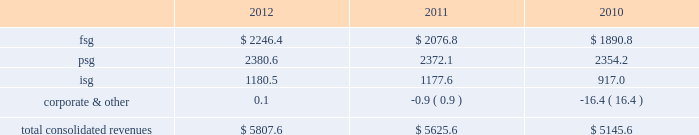Strategy our mission is to achieve sustainable revenue and earnings growth through providing superior solutions to our customers .
Our strategy to achieve this has been and will continue to be built on the following pillars : 2022 expand client relationships 2014 the overall market we serve continues to gravitate beyond single-product purchases to multi-solution partnerships .
As the market dynamics shift , we expect our clients to rely more on our multidimensional service offerings .
Our leveraged solutions and processing expertise can drive meaningful value and cost savings to our clients through more efficient operating processes , improved service quality and speed for our clients' customers .
2022 buy , build or partner to add solutions to cross-sell 2014 we continue to invest in growth through internal product development , as well as through product-focused or market-centric acquisitions that complement and extend our existing capabilities and provide us with additional solutions to cross-sell .
We also partner from time to time with other entities to provide comprehensive offerings to our customers .
By investing in solution innovation and integration , we continue to expand our value proposition to clients .
2022 support our clients through market transformation 2014 the changing market dynamics are transforming the way our clients operate , which is driving incremental demand for our leveraged solutions , consulting expertise , and services around intellectual property .
Our depth of services capabilities enables us to become involved earlier in the planning and design process to assist our clients as they manage through these changes .
2022 continually improve to drive margin expansion 2014 we strive to optimize our performance through investments in infrastructure enhancements and other measures that are designed to drive organic revenue growth and margin expansion .
2022 build global diversification 2014 we continue to deploy resources in emerging global markets where we expect to achieve meaningful scale .
Revenues by segment the table below summarizes the revenues by our reporting segments ( in millions ) : .
Financial solutions group the focus of fsg is to provide the most comprehensive software and services for the core processing , customer channel , treasury services , cash management , wealth management and capital market operations of our financial institution customers in north america .
We service the core and related ancillary processing needs of north american banks , credit unions , automotive financial companies , commercial lenders , and independent community and savings institutions .
Fis offers a broad selection of in-house and outsourced solutions to banking customers that span the range of asset sizes .
Fsg customers are typically committed under multi-year contracts that provide a stable , recurring revenue base and opportunities for cross-selling additional financial and payments offerings .
We employ several business models to provide our solutions to our customers .
We typically deliver the highest value to our customers when we combine our software applications and deliver them in one of several types of outsourcing arrangements , such as an application service provider , facilities management processing or an application management arrangement .
We are also able to deliver individual applications through a software licensing arrangement .
Based upon our expertise gained through the foregoing arrangements , some clients also retain us to manage their it operations without using any of our proprietary software .
Our solutions in this segment include: .
What percent of total consolidate revenue was the psg segment in 2011? 
Computations: (2372.1 / 5625.6)
Answer: 0.42166. 